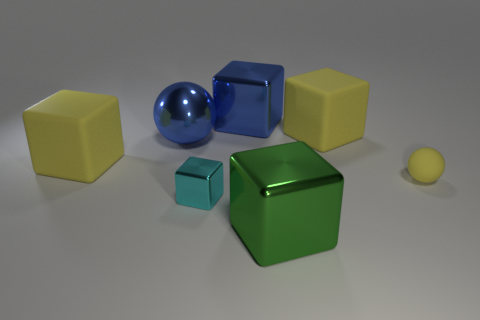There is a small rubber object that is right of the blue ball; what is its shape?
Your answer should be very brief. Sphere. What number of big blue metal objects are the same shape as the tiny cyan thing?
Keep it short and to the point. 1. Are there the same number of blue things left of the cyan metallic block and tiny cubes that are right of the blue metal sphere?
Your answer should be compact. Yes. Are there any small cyan blocks made of the same material as the small yellow ball?
Your answer should be very brief. No. Are the green block and the large blue cube made of the same material?
Make the answer very short. Yes. What number of blue things are metal blocks or large metal cubes?
Offer a very short reply. 1. Are there more small yellow things right of the small yellow thing than cubes?
Keep it short and to the point. No. Are there any large metallic blocks of the same color as the shiny sphere?
Your answer should be very brief. Yes. The green thing has what size?
Provide a succinct answer. Large. Is the color of the small metal object the same as the metallic sphere?
Your answer should be compact. No. 